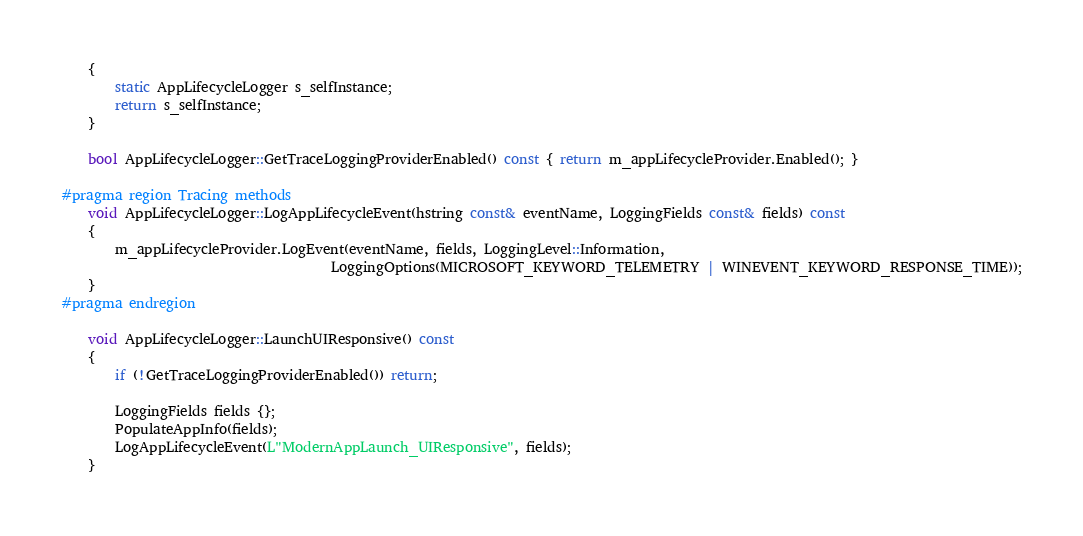Convert code to text. <code><loc_0><loc_0><loc_500><loc_500><_C++_>    {
        static AppLifecycleLogger s_selfInstance;
        return s_selfInstance;
    }

    bool AppLifecycleLogger::GetTraceLoggingProviderEnabled() const { return m_appLifecycleProvider.Enabled(); }

#pragma region Tracing methods
    void AppLifecycleLogger::LogAppLifecycleEvent(hstring const& eventName, LoggingFields const& fields) const
    {
        m_appLifecycleProvider.LogEvent(eventName, fields, LoggingLevel::Information,
                                        LoggingOptions(MICROSOFT_KEYWORD_TELEMETRY | WINEVENT_KEYWORD_RESPONSE_TIME));
    }
#pragma endregion

    void AppLifecycleLogger::LaunchUIResponsive() const
    {
        if (!GetTraceLoggingProviderEnabled()) return;

        LoggingFields fields {};
        PopulateAppInfo(fields);
        LogAppLifecycleEvent(L"ModernAppLaunch_UIResponsive", fields);
    }
</code> 